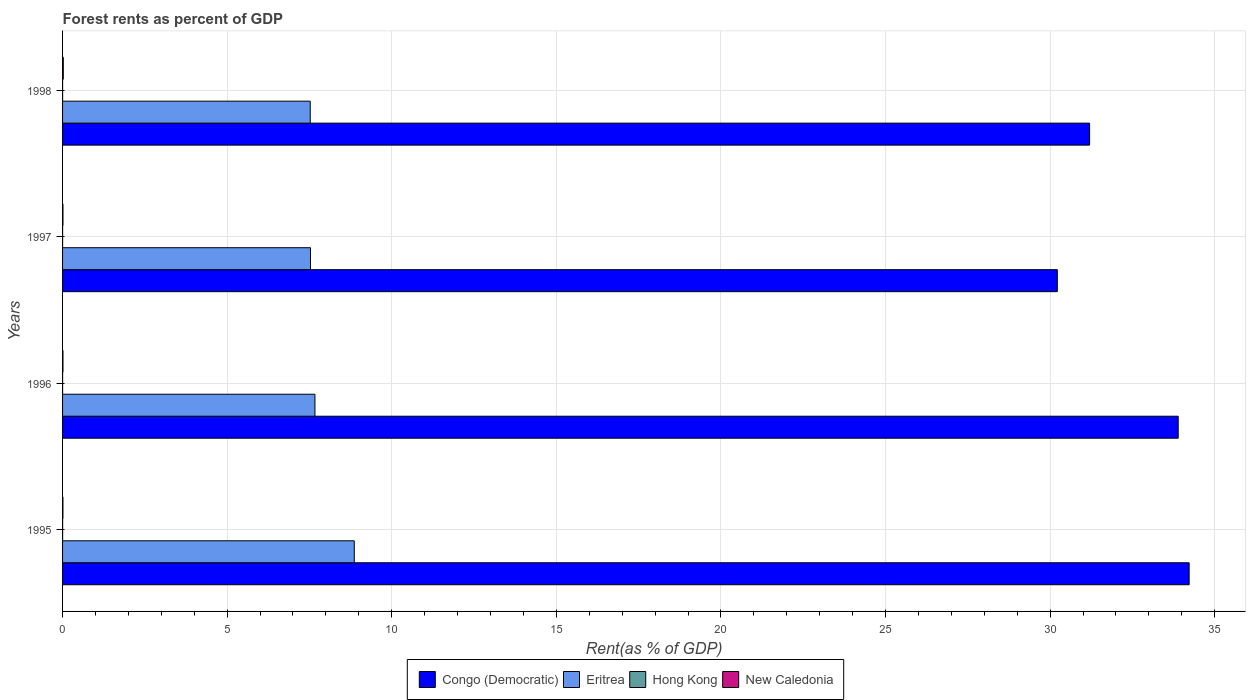How many groups of bars are there?
Your answer should be very brief. 4. How many bars are there on the 4th tick from the bottom?
Offer a terse response. 4. What is the label of the 1st group of bars from the top?
Your answer should be compact. 1998. In how many cases, is the number of bars for a given year not equal to the number of legend labels?
Ensure brevity in your answer.  0. What is the forest rent in Congo (Democratic) in 1995?
Your response must be concise. 34.22. Across all years, what is the maximum forest rent in Hong Kong?
Ensure brevity in your answer.  0. Across all years, what is the minimum forest rent in Congo (Democratic)?
Ensure brevity in your answer.  30.22. In which year was the forest rent in Hong Kong maximum?
Keep it short and to the point. 1995. In which year was the forest rent in Congo (Democratic) minimum?
Provide a short and direct response. 1997. What is the total forest rent in Congo (Democratic) in the graph?
Your response must be concise. 129.54. What is the difference between the forest rent in Eritrea in 1996 and that in 1997?
Keep it short and to the point. 0.14. What is the difference between the forest rent in Congo (Democratic) in 1996 and the forest rent in Eritrea in 1995?
Offer a very short reply. 25.03. What is the average forest rent in Congo (Democratic) per year?
Ensure brevity in your answer.  32.38. In the year 1995, what is the difference between the forest rent in New Caledonia and forest rent in Congo (Democratic)?
Ensure brevity in your answer.  -34.21. In how many years, is the forest rent in New Caledonia greater than 8 %?
Make the answer very short. 0. What is the ratio of the forest rent in Congo (Democratic) in 1997 to that in 1998?
Ensure brevity in your answer.  0.97. Is the forest rent in Congo (Democratic) in 1995 less than that in 1996?
Provide a short and direct response. No. What is the difference between the highest and the second highest forest rent in Eritrea?
Your answer should be very brief. 1.19. What is the difference between the highest and the lowest forest rent in Congo (Democratic)?
Make the answer very short. 4.01. Is the sum of the forest rent in New Caledonia in 1996 and 1997 greater than the maximum forest rent in Hong Kong across all years?
Give a very brief answer. Yes. Is it the case that in every year, the sum of the forest rent in Hong Kong and forest rent in Congo (Democratic) is greater than the sum of forest rent in Eritrea and forest rent in New Caledonia?
Give a very brief answer. No. What does the 2nd bar from the top in 1995 represents?
Your answer should be very brief. Hong Kong. What does the 2nd bar from the bottom in 1998 represents?
Your response must be concise. Eritrea. Is it the case that in every year, the sum of the forest rent in Eritrea and forest rent in New Caledonia is greater than the forest rent in Congo (Democratic)?
Make the answer very short. No. Are all the bars in the graph horizontal?
Your answer should be compact. Yes. Are the values on the major ticks of X-axis written in scientific E-notation?
Offer a terse response. No. Does the graph contain any zero values?
Your answer should be very brief. No. Does the graph contain grids?
Keep it short and to the point. Yes. How are the legend labels stacked?
Your answer should be compact. Horizontal. What is the title of the graph?
Offer a terse response. Forest rents as percent of GDP. Does "Qatar" appear as one of the legend labels in the graph?
Provide a succinct answer. No. What is the label or title of the X-axis?
Offer a terse response. Rent(as % of GDP). What is the label or title of the Y-axis?
Your response must be concise. Years. What is the Rent(as % of GDP) in Congo (Democratic) in 1995?
Your answer should be very brief. 34.22. What is the Rent(as % of GDP) of Eritrea in 1995?
Keep it short and to the point. 8.86. What is the Rent(as % of GDP) of Hong Kong in 1995?
Keep it short and to the point. 0. What is the Rent(as % of GDP) of New Caledonia in 1995?
Offer a very short reply. 0.01. What is the Rent(as % of GDP) in Congo (Democratic) in 1996?
Give a very brief answer. 33.89. What is the Rent(as % of GDP) in Eritrea in 1996?
Provide a short and direct response. 7.67. What is the Rent(as % of GDP) of Hong Kong in 1996?
Provide a succinct answer. 0. What is the Rent(as % of GDP) in New Caledonia in 1996?
Provide a short and direct response. 0.01. What is the Rent(as % of GDP) of Congo (Democratic) in 1997?
Provide a succinct answer. 30.22. What is the Rent(as % of GDP) of Eritrea in 1997?
Offer a very short reply. 7.53. What is the Rent(as % of GDP) of Hong Kong in 1997?
Provide a succinct answer. 0. What is the Rent(as % of GDP) in New Caledonia in 1997?
Offer a very short reply. 0.01. What is the Rent(as % of GDP) in Congo (Democratic) in 1998?
Provide a short and direct response. 31.2. What is the Rent(as % of GDP) in Eritrea in 1998?
Make the answer very short. 7.52. What is the Rent(as % of GDP) of Hong Kong in 1998?
Offer a terse response. 0. What is the Rent(as % of GDP) of New Caledonia in 1998?
Keep it short and to the point. 0.02. Across all years, what is the maximum Rent(as % of GDP) in Congo (Democratic)?
Ensure brevity in your answer.  34.22. Across all years, what is the maximum Rent(as % of GDP) of Eritrea?
Your answer should be compact. 8.86. Across all years, what is the maximum Rent(as % of GDP) in Hong Kong?
Keep it short and to the point. 0. Across all years, what is the maximum Rent(as % of GDP) of New Caledonia?
Provide a short and direct response. 0.02. Across all years, what is the minimum Rent(as % of GDP) of Congo (Democratic)?
Give a very brief answer. 30.22. Across all years, what is the minimum Rent(as % of GDP) in Eritrea?
Give a very brief answer. 7.52. Across all years, what is the minimum Rent(as % of GDP) in Hong Kong?
Your answer should be compact. 0. Across all years, what is the minimum Rent(as % of GDP) in New Caledonia?
Your response must be concise. 0.01. What is the total Rent(as % of GDP) of Congo (Democratic) in the graph?
Offer a very short reply. 129.54. What is the total Rent(as % of GDP) in Eritrea in the graph?
Keep it short and to the point. 31.58. What is the total Rent(as % of GDP) of Hong Kong in the graph?
Provide a short and direct response. 0. What is the total Rent(as % of GDP) of New Caledonia in the graph?
Keep it short and to the point. 0.06. What is the difference between the Rent(as % of GDP) of Congo (Democratic) in 1995 and that in 1996?
Offer a terse response. 0.33. What is the difference between the Rent(as % of GDP) of Eritrea in 1995 and that in 1996?
Provide a short and direct response. 1.19. What is the difference between the Rent(as % of GDP) of New Caledonia in 1995 and that in 1996?
Offer a terse response. -0. What is the difference between the Rent(as % of GDP) of Congo (Democratic) in 1995 and that in 1997?
Give a very brief answer. 4.01. What is the difference between the Rent(as % of GDP) in Eritrea in 1995 and that in 1997?
Keep it short and to the point. 1.33. What is the difference between the Rent(as % of GDP) of New Caledonia in 1995 and that in 1997?
Your answer should be compact. -0. What is the difference between the Rent(as % of GDP) of Congo (Democratic) in 1995 and that in 1998?
Ensure brevity in your answer.  3.02. What is the difference between the Rent(as % of GDP) of Eritrea in 1995 and that in 1998?
Give a very brief answer. 1.34. What is the difference between the Rent(as % of GDP) of New Caledonia in 1995 and that in 1998?
Give a very brief answer. -0.01. What is the difference between the Rent(as % of GDP) in Congo (Democratic) in 1996 and that in 1997?
Make the answer very short. 3.67. What is the difference between the Rent(as % of GDP) of Eritrea in 1996 and that in 1997?
Ensure brevity in your answer.  0.14. What is the difference between the Rent(as % of GDP) in New Caledonia in 1996 and that in 1997?
Make the answer very short. -0. What is the difference between the Rent(as % of GDP) of Congo (Democratic) in 1996 and that in 1998?
Offer a very short reply. 2.69. What is the difference between the Rent(as % of GDP) in Eritrea in 1996 and that in 1998?
Provide a succinct answer. 0.14. What is the difference between the Rent(as % of GDP) of Hong Kong in 1996 and that in 1998?
Offer a very short reply. -0. What is the difference between the Rent(as % of GDP) of New Caledonia in 1996 and that in 1998?
Provide a succinct answer. -0.01. What is the difference between the Rent(as % of GDP) in Congo (Democratic) in 1997 and that in 1998?
Your answer should be very brief. -0.98. What is the difference between the Rent(as % of GDP) in Eritrea in 1997 and that in 1998?
Offer a very short reply. 0.01. What is the difference between the Rent(as % of GDP) of Hong Kong in 1997 and that in 1998?
Offer a very short reply. -0. What is the difference between the Rent(as % of GDP) in New Caledonia in 1997 and that in 1998?
Provide a succinct answer. -0.01. What is the difference between the Rent(as % of GDP) of Congo (Democratic) in 1995 and the Rent(as % of GDP) of Eritrea in 1996?
Your answer should be very brief. 26.56. What is the difference between the Rent(as % of GDP) in Congo (Democratic) in 1995 and the Rent(as % of GDP) in Hong Kong in 1996?
Your response must be concise. 34.22. What is the difference between the Rent(as % of GDP) in Congo (Democratic) in 1995 and the Rent(as % of GDP) in New Caledonia in 1996?
Ensure brevity in your answer.  34.21. What is the difference between the Rent(as % of GDP) of Eritrea in 1995 and the Rent(as % of GDP) of Hong Kong in 1996?
Offer a very short reply. 8.86. What is the difference between the Rent(as % of GDP) of Eritrea in 1995 and the Rent(as % of GDP) of New Caledonia in 1996?
Keep it short and to the point. 8.85. What is the difference between the Rent(as % of GDP) in Hong Kong in 1995 and the Rent(as % of GDP) in New Caledonia in 1996?
Offer a terse response. -0.01. What is the difference between the Rent(as % of GDP) of Congo (Democratic) in 1995 and the Rent(as % of GDP) of Eritrea in 1997?
Provide a succinct answer. 26.69. What is the difference between the Rent(as % of GDP) of Congo (Democratic) in 1995 and the Rent(as % of GDP) of Hong Kong in 1997?
Your answer should be compact. 34.22. What is the difference between the Rent(as % of GDP) in Congo (Democratic) in 1995 and the Rent(as % of GDP) in New Caledonia in 1997?
Ensure brevity in your answer.  34.21. What is the difference between the Rent(as % of GDP) of Eritrea in 1995 and the Rent(as % of GDP) of Hong Kong in 1997?
Give a very brief answer. 8.86. What is the difference between the Rent(as % of GDP) of Eritrea in 1995 and the Rent(as % of GDP) of New Caledonia in 1997?
Your answer should be compact. 8.85. What is the difference between the Rent(as % of GDP) in Hong Kong in 1995 and the Rent(as % of GDP) in New Caledonia in 1997?
Offer a terse response. -0.01. What is the difference between the Rent(as % of GDP) in Congo (Democratic) in 1995 and the Rent(as % of GDP) in Eritrea in 1998?
Keep it short and to the point. 26.7. What is the difference between the Rent(as % of GDP) in Congo (Democratic) in 1995 and the Rent(as % of GDP) in Hong Kong in 1998?
Make the answer very short. 34.22. What is the difference between the Rent(as % of GDP) of Congo (Democratic) in 1995 and the Rent(as % of GDP) of New Caledonia in 1998?
Keep it short and to the point. 34.2. What is the difference between the Rent(as % of GDP) of Eritrea in 1995 and the Rent(as % of GDP) of Hong Kong in 1998?
Offer a very short reply. 8.86. What is the difference between the Rent(as % of GDP) in Eritrea in 1995 and the Rent(as % of GDP) in New Caledonia in 1998?
Provide a succinct answer. 8.84. What is the difference between the Rent(as % of GDP) in Hong Kong in 1995 and the Rent(as % of GDP) in New Caledonia in 1998?
Your response must be concise. -0.02. What is the difference between the Rent(as % of GDP) in Congo (Democratic) in 1996 and the Rent(as % of GDP) in Eritrea in 1997?
Keep it short and to the point. 26.36. What is the difference between the Rent(as % of GDP) in Congo (Democratic) in 1996 and the Rent(as % of GDP) in Hong Kong in 1997?
Your answer should be compact. 33.89. What is the difference between the Rent(as % of GDP) of Congo (Democratic) in 1996 and the Rent(as % of GDP) of New Caledonia in 1997?
Your answer should be compact. 33.88. What is the difference between the Rent(as % of GDP) in Eritrea in 1996 and the Rent(as % of GDP) in Hong Kong in 1997?
Provide a succinct answer. 7.67. What is the difference between the Rent(as % of GDP) of Eritrea in 1996 and the Rent(as % of GDP) of New Caledonia in 1997?
Your answer should be compact. 7.65. What is the difference between the Rent(as % of GDP) in Hong Kong in 1996 and the Rent(as % of GDP) in New Caledonia in 1997?
Give a very brief answer. -0.01. What is the difference between the Rent(as % of GDP) of Congo (Democratic) in 1996 and the Rent(as % of GDP) of Eritrea in 1998?
Your answer should be compact. 26.37. What is the difference between the Rent(as % of GDP) in Congo (Democratic) in 1996 and the Rent(as % of GDP) in Hong Kong in 1998?
Make the answer very short. 33.89. What is the difference between the Rent(as % of GDP) of Congo (Democratic) in 1996 and the Rent(as % of GDP) of New Caledonia in 1998?
Your answer should be compact. 33.87. What is the difference between the Rent(as % of GDP) of Eritrea in 1996 and the Rent(as % of GDP) of Hong Kong in 1998?
Your answer should be compact. 7.67. What is the difference between the Rent(as % of GDP) in Eritrea in 1996 and the Rent(as % of GDP) in New Caledonia in 1998?
Make the answer very short. 7.64. What is the difference between the Rent(as % of GDP) of Hong Kong in 1996 and the Rent(as % of GDP) of New Caledonia in 1998?
Keep it short and to the point. -0.02. What is the difference between the Rent(as % of GDP) in Congo (Democratic) in 1997 and the Rent(as % of GDP) in Eritrea in 1998?
Your response must be concise. 22.7. What is the difference between the Rent(as % of GDP) in Congo (Democratic) in 1997 and the Rent(as % of GDP) in Hong Kong in 1998?
Give a very brief answer. 30.22. What is the difference between the Rent(as % of GDP) of Congo (Democratic) in 1997 and the Rent(as % of GDP) of New Caledonia in 1998?
Your answer should be compact. 30.2. What is the difference between the Rent(as % of GDP) of Eritrea in 1997 and the Rent(as % of GDP) of Hong Kong in 1998?
Offer a terse response. 7.53. What is the difference between the Rent(as % of GDP) in Eritrea in 1997 and the Rent(as % of GDP) in New Caledonia in 1998?
Your response must be concise. 7.51. What is the difference between the Rent(as % of GDP) of Hong Kong in 1997 and the Rent(as % of GDP) of New Caledonia in 1998?
Keep it short and to the point. -0.02. What is the average Rent(as % of GDP) of Congo (Democratic) per year?
Offer a terse response. 32.38. What is the average Rent(as % of GDP) in Eritrea per year?
Your answer should be very brief. 7.9. What is the average Rent(as % of GDP) of New Caledonia per year?
Your response must be concise. 0.01. In the year 1995, what is the difference between the Rent(as % of GDP) in Congo (Democratic) and Rent(as % of GDP) in Eritrea?
Give a very brief answer. 25.36. In the year 1995, what is the difference between the Rent(as % of GDP) in Congo (Democratic) and Rent(as % of GDP) in Hong Kong?
Your answer should be compact. 34.22. In the year 1995, what is the difference between the Rent(as % of GDP) in Congo (Democratic) and Rent(as % of GDP) in New Caledonia?
Your response must be concise. 34.21. In the year 1995, what is the difference between the Rent(as % of GDP) in Eritrea and Rent(as % of GDP) in Hong Kong?
Offer a terse response. 8.86. In the year 1995, what is the difference between the Rent(as % of GDP) of Eritrea and Rent(as % of GDP) of New Caledonia?
Your response must be concise. 8.85. In the year 1995, what is the difference between the Rent(as % of GDP) of Hong Kong and Rent(as % of GDP) of New Caledonia?
Keep it short and to the point. -0.01. In the year 1996, what is the difference between the Rent(as % of GDP) of Congo (Democratic) and Rent(as % of GDP) of Eritrea?
Keep it short and to the point. 26.23. In the year 1996, what is the difference between the Rent(as % of GDP) of Congo (Democratic) and Rent(as % of GDP) of Hong Kong?
Make the answer very short. 33.89. In the year 1996, what is the difference between the Rent(as % of GDP) in Congo (Democratic) and Rent(as % of GDP) in New Caledonia?
Keep it short and to the point. 33.88. In the year 1996, what is the difference between the Rent(as % of GDP) in Eritrea and Rent(as % of GDP) in Hong Kong?
Your response must be concise. 7.67. In the year 1996, what is the difference between the Rent(as % of GDP) of Eritrea and Rent(as % of GDP) of New Caledonia?
Keep it short and to the point. 7.65. In the year 1996, what is the difference between the Rent(as % of GDP) of Hong Kong and Rent(as % of GDP) of New Caledonia?
Ensure brevity in your answer.  -0.01. In the year 1997, what is the difference between the Rent(as % of GDP) in Congo (Democratic) and Rent(as % of GDP) in Eritrea?
Offer a very short reply. 22.69. In the year 1997, what is the difference between the Rent(as % of GDP) of Congo (Democratic) and Rent(as % of GDP) of Hong Kong?
Your response must be concise. 30.22. In the year 1997, what is the difference between the Rent(as % of GDP) in Congo (Democratic) and Rent(as % of GDP) in New Caledonia?
Your answer should be compact. 30.21. In the year 1997, what is the difference between the Rent(as % of GDP) of Eritrea and Rent(as % of GDP) of Hong Kong?
Make the answer very short. 7.53. In the year 1997, what is the difference between the Rent(as % of GDP) of Eritrea and Rent(as % of GDP) of New Caledonia?
Provide a succinct answer. 7.52. In the year 1997, what is the difference between the Rent(as % of GDP) in Hong Kong and Rent(as % of GDP) in New Caledonia?
Ensure brevity in your answer.  -0.01. In the year 1998, what is the difference between the Rent(as % of GDP) in Congo (Democratic) and Rent(as % of GDP) in Eritrea?
Offer a very short reply. 23.68. In the year 1998, what is the difference between the Rent(as % of GDP) of Congo (Democratic) and Rent(as % of GDP) of Hong Kong?
Ensure brevity in your answer.  31.2. In the year 1998, what is the difference between the Rent(as % of GDP) of Congo (Democratic) and Rent(as % of GDP) of New Caledonia?
Offer a terse response. 31.18. In the year 1998, what is the difference between the Rent(as % of GDP) in Eritrea and Rent(as % of GDP) in Hong Kong?
Provide a succinct answer. 7.52. In the year 1998, what is the difference between the Rent(as % of GDP) of Eritrea and Rent(as % of GDP) of New Caledonia?
Offer a very short reply. 7.5. In the year 1998, what is the difference between the Rent(as % of GDP) of Hong Kong and Rent(as % of GDP) of New Caledonia?
Your response must be concise. -0.02. What is the ratio of the Rent(as % of GDP) in Congo (Democratic) in 1995 to that in 1996?
Your answer should be compact. 1.01. What is the ratio of the Rent(as % of GDP) of Eritrea in 1995 to that in 1996?
Your answer should be compact. 1.16. What is the ratio of the Rent(as % of GDP) in Hong Kong in 1995 to that in 1996?
Offer a very short reply. 1.18. What is the ratio of the Rent(as % of GDP) in New Caledonia in 1995 to that in 1996?
Your answer should be very brief. 0.94. What is the ratio of the Rent(as % of GDP) of Congo (Democratic) in 1995 to that in 1997?
Provide a short and direct response. 1.13. What is the ratio of the Rent(as % of GDP) of Eritrea in 1995 to that in 1997?
Provide a short and direct response. 1.18. What is the ratio of the Rent(as % of GDP) of Hong Kong in 1995 to that in 1997?
Your response must be concise. 1.13. What is the ratio of the Rent(as % of GDP) of New Caledonia in 1995 to that in 1997?
Your answer should be very brief. 0.92. What is the ratio of the Rent(as % of GDP) in Congo (Democratic) in 1995 to that in 1998?
Make the answer very short. 1.1. What is the ratio of the Rent(as % of GDP) of Eritrea in 1995 to that in 1998?
Ensure brevity in your answer.  1.18. What is the ratio of the Rent(as % of GDP) of Hong Kong in 1995 to that in 1998?
Offer a terse response. 1.11. What is the ratio of the Rent(as % of GDP) of New Caledonia in 1995 to that in 1998?
Your answer should be very brief. 0.51. What is the ratio of the Rent(as % of GDP) of Congo (Democratic) in 1996 to that in 1997?
Provide a succinct answer. 1.12. What is the ratio of the Rent(as % of GDP) of Eritrea in 1996 to that in 1997?
Your answer should be compact. 1.02. What is the ratio of the Rent(as % of GDP) of Hong Kong in 1996 to that in 1997?
Your answer should be very brief. 0.97. What is the ratio of the Rent(as % of GDP) in New Caledonia in 1996 to that in 1997?
Keep it short and to the point. 0.98. What is the ratio of the Rent(as % of GDP) in Congo (Democratic) in 1996 to that in 1998?
Your answer should be very brief. 1.09. What is the ratio of the Rent(as % of GDP) in New Caledonia in 1996 to that in 1998?
Keep it short and to the point. 0.54. What is the ratio of the Rent(as % of GDP) in Congo (Democratic) in 1997 to that in 1998?
Give a very brief answer. 0.97. What is the ratio of the Rent(as % of GDP) in New Caledonia in 1997 to that in 1998?
Make the answer very short. 0.55. What is the difference between the highest and the second highest Rent(as % of GDP) of Congo (Democratic)?
Make the answer very short. 0.33. What is the difference between the highest and the second highest Rent(as % of GDP) of Eritrea?
Ensure brevity in your answer.  1.19. What is the difference between the highest and the second highest Rent(as % of GDP) in Hong Kong?
Offer a very short reply. 0. What is the difference between the highest and the second highest Rent(as % of GDP) of New Caledonia?
Give a very brief answer. 0.01. What is the difference between the highest and the lowest Rent(as % of GDP) of Congo (Democratic)?
Your response must be concise. 4.01. What is the difference between the highest and the lowest Rent(as % of GDP) in Eritrea?
Ensure brevity in your answer.  1.34. What is the difference between the highest and the lowest Rent(as % of GDP) in New Caledonia?
Your response must be concise. 0.01. 